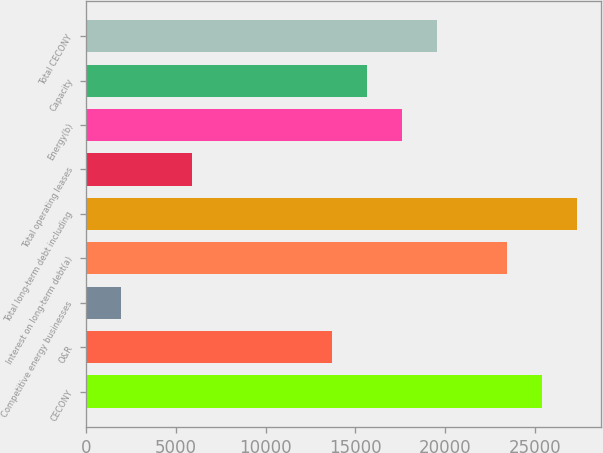Convert chart to OTSL. <chart><loc_0><loc_0><loc_500><loc_500><bar_chart><fcel>CECONY<fcel>O&R<fcel>Competitive energy businesses<fcel>Interest on long-term debt(a)<fcel>Total long-term debt including<fcel>Total operating leases<fcel>Energy(b)<fcel>Capacity<fcel>Total CECONY<nl><fcel>25386.8<fcel>13671.2<fcel>1955.6<fcel>23434.2<fcel>27339.4<fcel>5860.8<fcel>17576.4<fcel>15623.8<fcel>19529<nl></chart> 